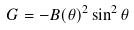<formula> <loc_0><loc_0><loc_500><loc_500>G = - B ( \theta ) ^ { 2 } \sin ^ { 2 } \theta</formula> 